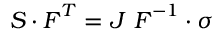Convert formula to latex. <formula><loc_0><loc_0><loc_500><loc_500>{ S } \cdot { F } ^ { T } = J { F } ^ { - 1 } \cdot { \sigma }</formula> 